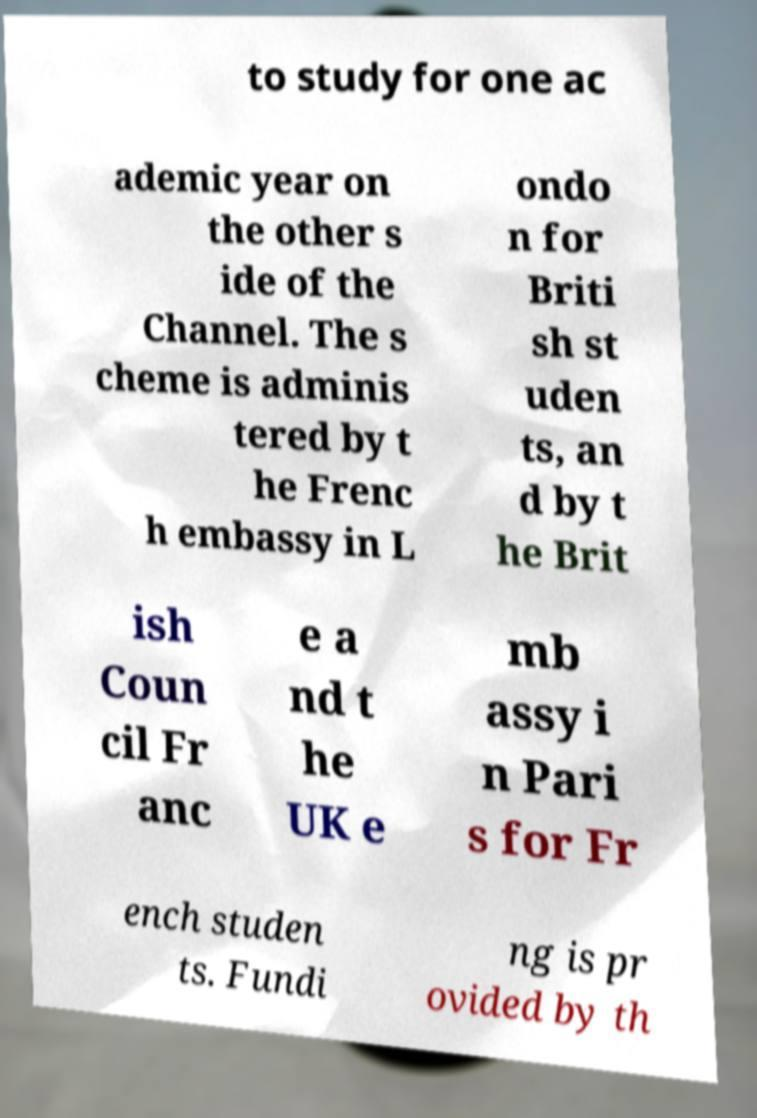Please read and relay the text visible in this image. What does it say? to study for one ac ademic year on the other s ide of the Channel. The s cheme is adminis tered by t he Frenc h embassy in L ondo n for Briti sh st uden ts, an d by t he Brit ish Coun cil Fr anc e a nd t he UK e mb assy i n Pari s for Fr ench studen ts. Fundi ng is pr ovided by th 